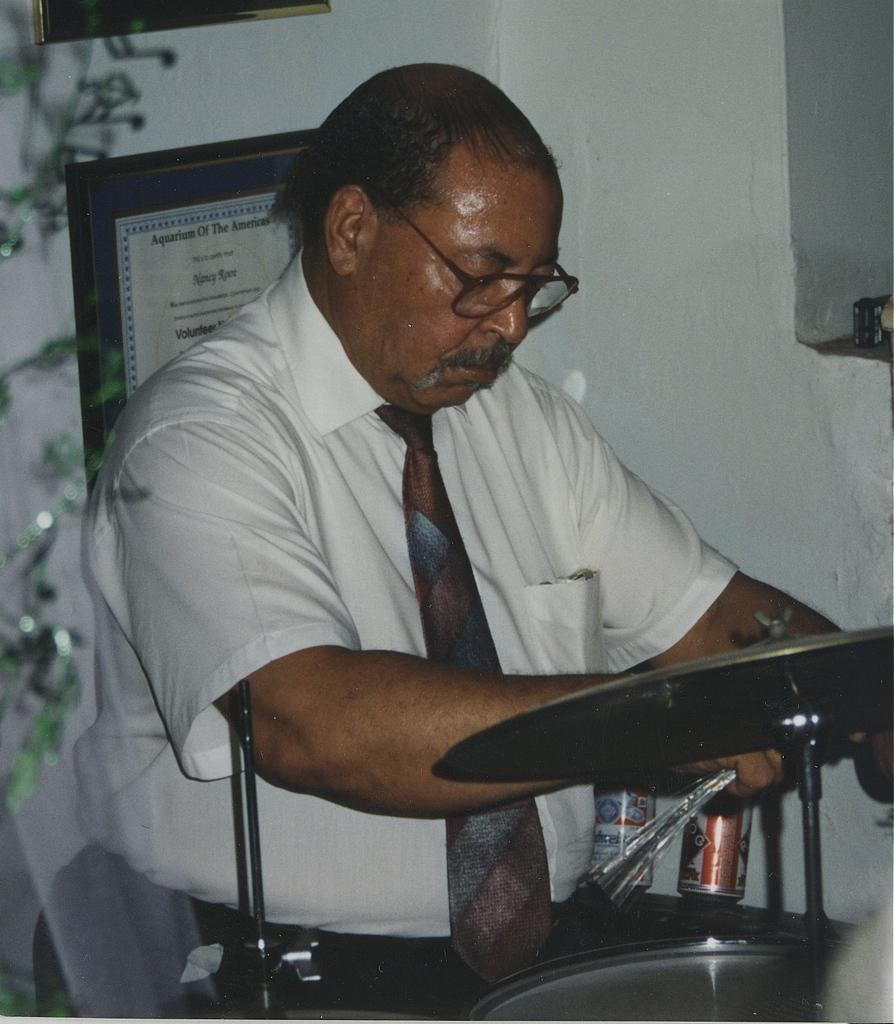Who is the main subject in the image? There is an old man in the image. What is the old man wearing? The old man is wearing a white shirt and tie. What is the old man standing in front of? The old man is standing in front of a treadmill. What can be seen in the background of the image? There is a wall in the background of the image. What is hanging on the wall? There is a certificate on the wall. How much weight can the step in the image hold? There is no step present in the image, only a treadmill. 